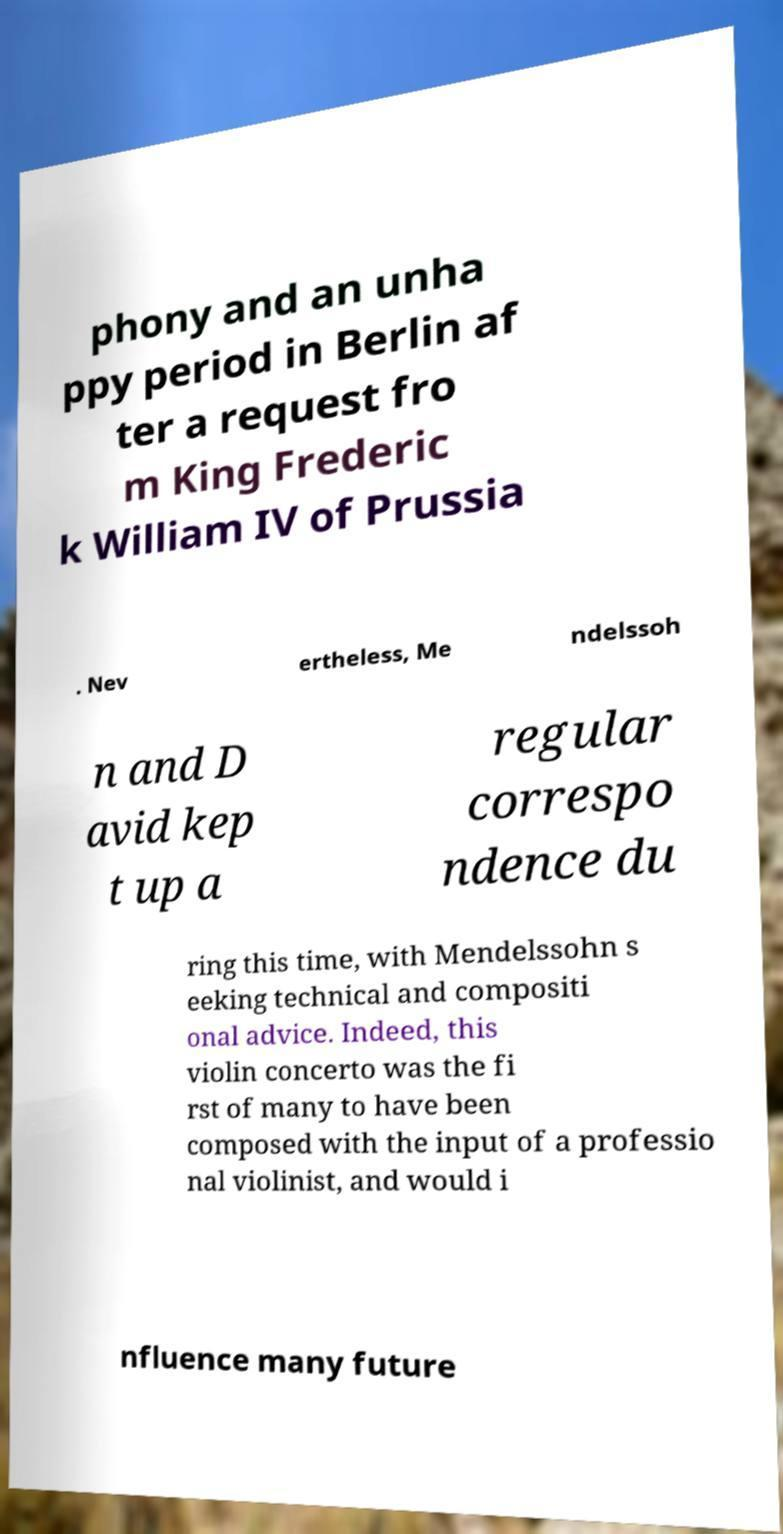What messages or text are displayed in this image? I need them in a readable, typed format. phony and an unha ppy period in Berlin af ter a request fro m King Frederic k William IV of Prussia . Nev ertheless, Me ndelssoh n and D avid kep t up a regular correspo ndence du ring this time, with Mendelssohn s eeking technical and compositi onal advice. Indeed, this violin concerto was the fi rst of many to have been composed with the input of a professio nal violinist, and would i nfluence many future 